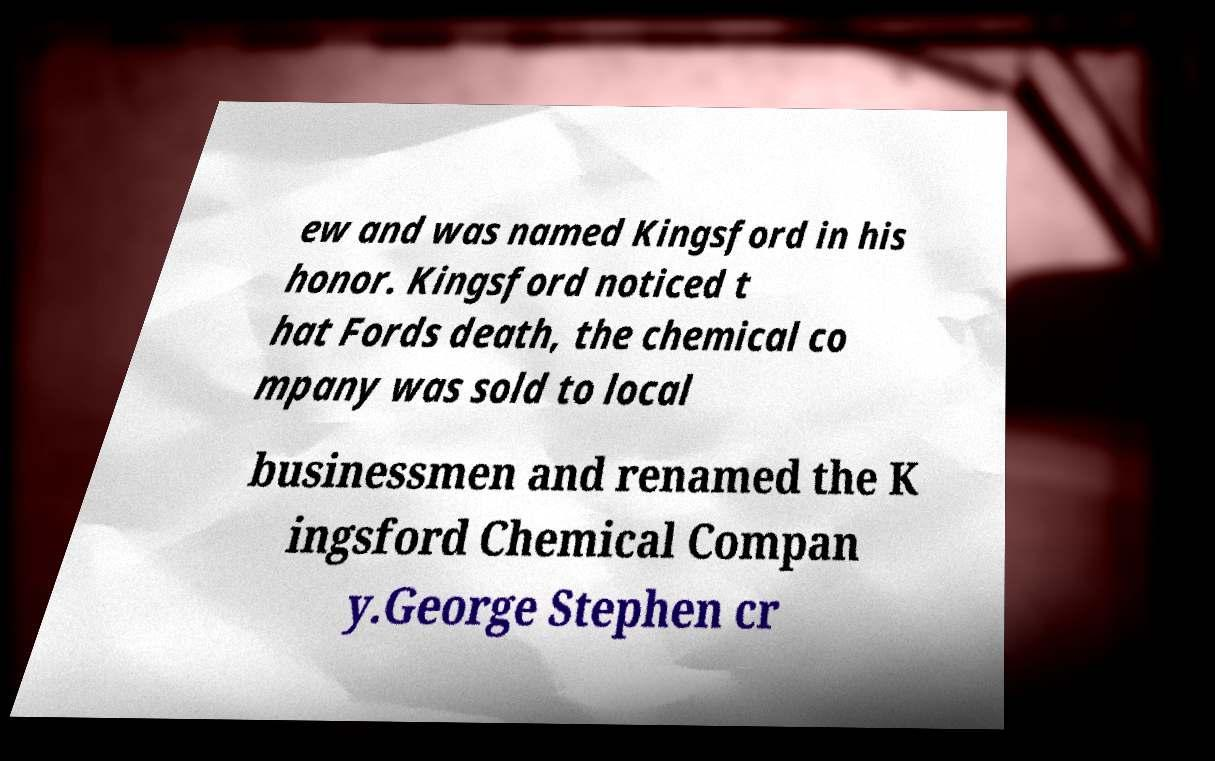For documentation purposes, I need the text within this image transcribed. Could you provide that? ew and was named Kingsford in his honor. Kingsford noticed t hat Fords death, the chemical co mpany was sold to local businessmen and renamed the K ingsford Chemical Compan y.George Stephen cr 